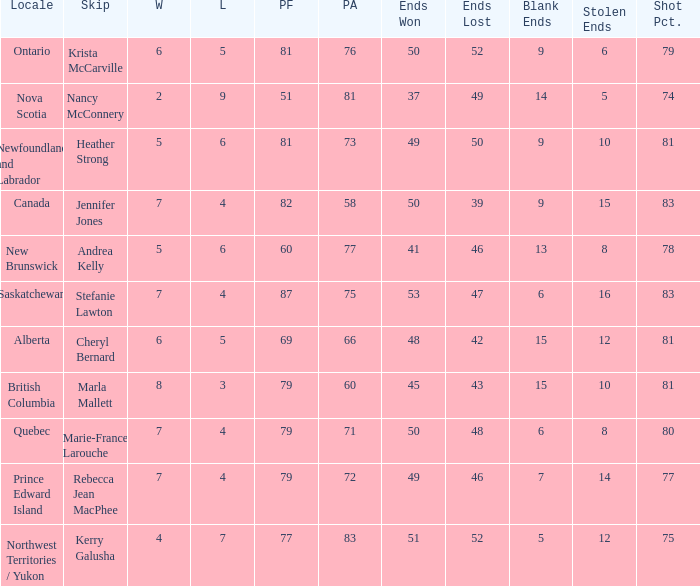What is the total of blank ends at Prince Edward Island? 7.0. 